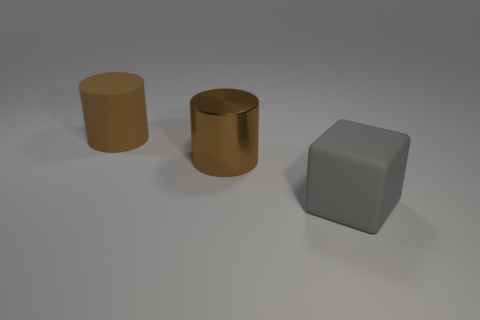How many brown cylinders must be subtracted to get 1 brown cylinders? 1 Add 2 shiny things. How many objects exist? 5 Subtract all cylinders. How many objects are left? 1 Subtract all big things. Subtract all small brown spheres. How many objects are left? 0 Add 1 gray rubber blocks. How many gray rubber blocks are left? 2 Add 3 gray spheres. How many gray spheres exist? 3 Subtract 0 purple spheres. How many objects are left? 3 